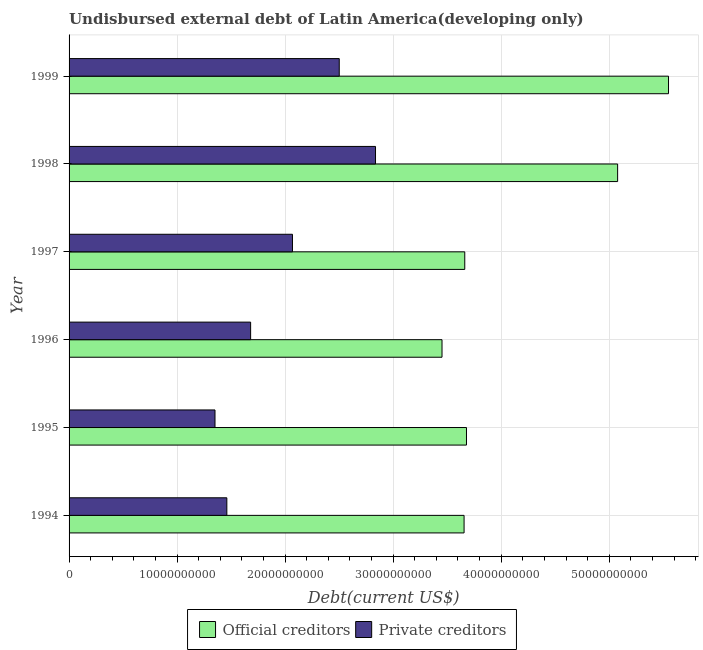Are the number of bars on each tick of the Y-axis equal?
Give a very brief answer. Yes. How many bars are there on the 2nd tick from the top?
Offer a terse response. 2. What is the undisbursed external debt of private creditors in 1994?
Make the answer very short. 1.46e+1. Across all years, what is the maximum undisbursed external debt of private creditors?
Provide a short and direct response. 2.84e+1. Across all years, what is the minimum undisbursed external debt of official creditors?
Offer a terse response. 3.45e+1. In which year was the undisbursed external debt of official creditors maximum?
Your answer should be compact. 1999. What is the total undisbursed external debt of private creditors in the graph?
Offer a terse response. 1.19e+11. What is the difference between the undisbursed external debt of private creditors in 1994 and that in 1999?
Make the answer very short. -1.04e+1. What is the difference between the undisbursed external debt of official creditors in 1996 and the undisbursed external debt of private creditors in 1994?
Your answer should be compact. 1.99e+1. What is the average undisbursed external debt of official creditors per year?
Your answer should be compact. 4.18e+1. In the year 1998, what is the difference between the undisbursed external debt of private creditors and undisbursed external debt of official creditors?
Offer a very short reply. -2.24e+1. In how many years, is the undisbursed external debt of private creditors greater than 48000000000 US$?
Offer a very short reply. 0. What is the ratio of the undisbursed external debt of private creditors in 1995 to that in 1999?
Your answer should be very brief. 0.54. Is the undisbursed external debt of private creditors in 1997 less than that in 1998?
Make the answer very short. Yes. Is the difference between the undisbursed external debt of official creditors in 1997 and 1998 greater than the difference between the undisbursed external debt of private creditors in 1997 and 1998?
Ensure brevity in your answer.  No. What is the difference between the highest and the second highest undisbursed external debt of official creditors?
Offer a very short reply. 4.71e+09. What is the difference between the highest and the lowest undisbursed external debt of official creditors?
Your response must be concise. 2.10e+1. In how many years, is the undisbursed external debt of private creditors greater than the average undisbursed external debt of private creditors taken over all years?
Provide a succinct answer. 3. What does the 2nd bar from the top in 1994 represents?
Make the answer very short. Official creditors. What does the 1st bar from the bottom in 1997 represents?
Provide a short and direct response. Official creditors. How many bars are there?
Your response must be concise. 12. How many years are there in the graph?
Provide a succinct answer. 6. What is the difference between two consecutive major ticks on the X-axis?
Keep it short and to the point. 1.00e+1. Are the values on the major ticks of X-axis written in scientific E-notation?
Offer a terse response. No. Does the graph contain grids?
Provide a short and direct response. Yes. What is the title of the graph?
Provide a succinct answer. Undisbursed external debt of Latin America(developing only). Does "Travel Items" appear as one of the legend labels in the graph?
Your answer should be compact. No. What is the label or title of the X-axis?
Provide a short and direct response. Debt(current US$). What is the Debt(current US$) in Official creditors in 1994?
Provide a short and direct response. 3.66e+1. What is the Debt(current US$) of Private creditors in 1994?
Offer a terse response. 1.46e+1. What is the Debt(current US$) of Official creditors in 1995?
Your response must be concise. 3.68e+1. What is the Debt(current US$) of Private creditors in 1995?
Provide a succinct answer. 1.35e+1. What is the Debt(current US$) of Official creditors in 1996?
Offer a very short reply. 3.45e+1. What is the Debt(current US$) of Private creditors in 1996?
Give a very brief answer. 1.68e+1. What is the Debt(current US$) in Official creditors in 1997?
Your answer should be very brief. 3.66e+1. What is the Debt(current US$) in Private creditors in 1997?
Your answer should be very brief. 2.07e+1. What is the Debt(current US$) of Official creditors in 1998?
Provide a succinct answer. 5.08e+1. What is the Debt(current US$) in Private creditors in 1998?
Provide a succinct answer. 2.84e+1. What is the Debt(current US$) in Official creditors in 1999?
Offer a terse response. 5.55e+1. What is the Debt(current US$) in Private creditors in 1999?
Your answer should be very brief. 2.50e+1. Across all years, what is the maximum Debt(current US$) in Official creditors?
Your answer should be compact. 5.55e+1. Across all years, what is the maximum Debt(current US$) in Private creditors?
Your answer should be very brief. 2.84e+1. Across all years, what is the minimum Debt(current US$) in Official creditors?
Keep it short and to the point. 3.45e+1. Across all years, what is the minimum Debt(current US$) in Private creditors?
Your answer should be compact. 1.35e+1. What is the total Debt(current US$) of Official creditors in the graph?
Provide a short and direct response. 2.51e+11. What is the total Debt(current US$) in Private creditors in the graph?
Offer a terse response. 1.19e+11. What is the difference between the Debt(current US$) in Official creditors in 1994 and that in 1995?
Keep it short and to the point. -2.23e+08. What is the difference between the Debt(current US$) of Private creditors in 1994 and that in 1995?
Keep it short and to the point. 1.10e+09. What is the difference between the Debt(current US$) of Official creditors in 1994 and that in 1996?
Offer a very short reply. 2.04e+09. What is the difference between the Debt(current US$) of Private creditors in 1994 and that in 1996?
Your answer should be very brief. -2.20e+09. What is the difference between the Debt(current US$) in Official creditors in 1994 and that in 1997?
Offer a very short reply. -6.36e+07. What is the difference between the Debt(current US$) in Private creditors in 1994 and that in 1997?
Your answer should be compact. -6.07e+09. What is the difference between the Debt(current US$) in Official creditors in 1994 and that in 1998?
Offer a terse response. -1.42e+1. What is the difference between the Debt(current US$) in Private creditors in 1994 and that in 1998?
Make the answer very short. -1.38e+1. What is the difference between the Debt(current US$) of Official creditors in 1994 and that in 1999?
Give a very brief answer. -1.89e+1. What is the difference between the Debt(current US$) in Private creditors in 1994 and that in 1999?
Your response must be concise. -1.04e+1. What is the difference between the Debt(current US$) of Official creditors in 1995 and that in 1996?
Give a very brief answer. 2.27e+09. What is the difference between the Debt(current US$) of Private creditors in 1995 and that in 1996?
Your response must be concise. -3.30e+09. What is the difference between the Debt(current US$) of Official creditors in 1995 and that in 1997?
Provide a short and direct response. 1.60e+08. What is the difference between the Debt(current US$) of Private creditors in 1995 and that in 1997?
Keep it short and to the point. -7.17e+09. What is the difference between the Debt(current US$) of Official creditors in 1995 and that in 1998?
Provide a succinct answer. -1.40e+1. What is the difference between the Debt(current US$) in Private creditors in 1995 and that in 1998?
Ensure brevity in your answer.  -1.49e+1. What is the difference between the Debt(current US$) in Official creditors in 1995 and that in 1999?
Make the answer very short. -1.87e+1. What is the difference between the Debt(current US$) in Private creditors in 1995 and that in 1999?
Offer a very short reply. -1.15e+1. What is the difference between the Debt(current US$) in Official creditors in 1996 and that in 1997?
Give a very brief answer. -2.11e+09. What is the difference between the Debt(current US$) of Private creditors in 1996 and that in 1997?
Offer a very short reply. -3.87e+09. What is the difference between the Debt(current US$) of Official creditors in 1996 and that in 1998?
Provide a short and direct response. -1.63e+1. What is the difference between the Debt(current US$) of Private creditors in 1996 and that in 1998?
Make the answer very short. -1.16e+1. What is the difference between the Debt(current US$) of Official creditors in 1996 and that in 1999?
Your response must be concise. -2.10e+1. What is the difference between the Debt(current US$) in Private creditors in 1996 and that in 1999?
Give a very brief answer. -8.20e+09. What is the difference between the Debt(current US$) of Official creditors in 1997 and that in 1998?
Offer a very short reply. -1.42e+1. What is the difference between the Debt(current US$) in Private creditors in 1997 and that in 1998?
Keep it short and to the point. -7.69e+09. What is the difference between the Debt(current US$) in Official creditors in 1997 and that in 1999?
Offer a very short reply. -1.89e+1. What is the difference between the Debt(current US$) of Private creditors in 1997 and that in 1999?
Keep it short and to the point. -4.33e+09. What is the difference between the Debt(current US$) in Official creditors in 1998 and that in 1999?
Make the answer very short. -4.71e+09. What is the difference between the Debt(current US$) of Private creditors in 1998 and that in 1999?
Your answer should be very brief. 3.36e+09. What is the difference between the Debt(current US$) of Official creditors in 1994 and the Debt(current US$) of Private creditors in 1995?
Offer a very short reply. 2.31e+1. What is the difference between the Debt(current US$) in Official creditors in 1994 and the Debt(current US$) in Private creditors in 1996?
Ensure brevity in your answer.  1.98e+1. What is the difference between the Debt(current US$) in Official creditors in 1994 and the Debt(current US$) in Private creditors in 1997?
Your response must be concise. 1.59e+1. What is the difference between the Debt(current US$) of Official creditors in 1994 and the Debt(current US$) of Private creditors in 1998?
Keep it short and to the point. 8.20e+09. What is the difference between the Debt(current US$) of Official creditors in 1994 and the Debt(current US$) of Private creditors in 1999?
Your response must be concise. 1.16e+1. What is the difference between the Debt(current US$) in Official creditors in 1995 and the Debt(current US$) in Private creditors in 1996?
Your answer should be very brief. 2.00e+1. What is the difference between the Debt(current US$) of Official creditors in 1995 and the Debt(current US$) of Private creditors in 1997?
Give a very brief answer. 1.61e+1. What is the difference between the Debt(current US$) in Official creditors in 1995 and the Debt(current US$) in Private creditors in 1998?
Offer a very short reply. 8.42e+09. What is the difference between the Debt(current US$) in Official creditors in 1995 and the Debt(current US$) in Private creditors in 1999?
Your answer should be compact. 1.18e+1. What is the difference between the Debt(current US$) of Official creditors in 1996 and the Debt(current US$) of Private creditors in 1997?
Your answer should be very brief. 1.38e+1. What is the difference between the Debt(current US$) in Official creditors in 1996 and the Debt(current US$) in Private creditors in 1998?
Give a very brief answer. 6.16e+09. What is the difference between the Debt(current US$) of Official creditors in 1996 and the Debt(current US$) of Private creditors in 1999?
Provide a short and direct response. 9.51e+09. What is the difference between the Debt(current US$) in Official creditors in 1997 and the Debt(current US$) in Private creditors in 1998?
Make the answer very short. 8.26e+09. What is the difference between the Debt(current US$) of Official creditors in 1997 and the Debt(current US$) of Private creditors in 1999?
Provide a succinct answer. 1.16e+1. What is the difference between the Debt(current US$) of Official creditors in 1998 and the Debt(current US$) of Private creditors in 1999?
Ensure brevity in your answer.  2.58e+1. What is the average Debt(current US$) of Official creditors per year?
Give a very brief answer. 4.18e+1. What is the average Debt(current US$) of Private creditors per year?
Offer a terse response. 1.98e+1. In the year 1994, what is the difference between the Debt(current US$) in Official creditors and Debt(current US$) in Private creditors?
Your response must be concise. 2.20e+1. In the year 1995, what is the difference between the Debt(current US$) of Official creditors and Debt(current US$) of Private creditors?
Give a very brief answer. 2.33e+1. In the year 1996, what is the difference between the Debt(current US$) in Official creditors and Debt(current US$) in Private creditors?
Offer a terse response. 1.77e+1. In the year 1997, what is the difference between the Debt(current US$) of Official creditors and Debt(current US$) of Private creditors?
Your answer should be very brief. 1.59e+1. In the year 1998, what is the difference between the Debt(current US$) of Official creditors and Debt(current US$) of Private creditors?
Offer a terse response. 2.24e+1. In the year 1999, what is the difference between the Debt(current US$) in Official creditors and Debt(current US$) in Private creditors?
Keep it short and to the point. 3.05e+1. What is the ratio of the Debt(current US$) in Official creditors in 1994 to that in 1995?
Offer a very short reply. 0.99. What is the ratio of the Debt(current US$) in Private creditors in 1994 to that in 1995?
Offer a terse response. 1.08. What is the ratio of the Debt(current US$) in Official creditors in 1994 to that in 1996?
Provide a succinct answer. 1.06. What is the ratio of the Debt(current US$) in Private creditors in 1994 to that in 1996?
Make the answer very short. 0.87. What is the ratio of the Debt(current US$) in Official creditors in 1994 to that in 1997?
Give a very brief answer. 1. What is the ratio of the Debt(current US$) in Private creditors in 1994 to that in 1997?
Provide a succinct answer. 0.71. What is the ratio of the Debt(current US$) of Official creditors in 1994 to that in 1998?
Give a very brief answer. 0.72. What is the ratio of the Debt(current US$) of Private creditors in 1994 to that in 1998?
Keep it short and to the point. 0.51. What is the ratio of the Debt(current US$) in Official creditors in 1994 to that in 1999?
Provide a short and direct response. 0.66. What is the ratio of the Debt(current US$) in Private creditors in 1994 to that in 1999?
Offer a very short reply. 0.58. What is the ratio of the Debt(current US$) of Official creditors in 1995 to that in 1996?
Your answer should be compact. 1.07. What is the ratio of the Debt(current US$) in Private creditors in 1995 to that in 1996?
Keep it short and to the point. 0.8. What is the ratio of the Debt(current US$) of Official creditors in 1995 to that in 1997?
Offer a terse response. 1. What is the ratio of the Debt(current US$) in Private creditors in 1995 to that in 1997?
Your response must be concise. 0.65. What is the ratio of the Debt(current US$) in Official creditors in 1995 to that in 1998?
Your answer should be very brief. 0.72. What is the ratio of the Debt(current US$) of Private creditors in 1995 to that in 1998?
Keep it short and to the point. 0.48. What is the ratio of the Debt(current US$) in Official creditors in 1995 to that in 1999?
Keep it short and to the point. 0.66. What is the ratio of the Debt(current US$) of Private creditors in 1995 to that in 1999?
Your answer should be very brief. 0.54. What is the ratio of the Debt(current US$) of Official creditors in 1996 to that in 1997?
Ensure brevity in your answer.  0.94. What is the ratio of the Debt(current US$) of Private creditors in 1996 to that in 1997?
Provide a succinct answer. 0.81. What is the ratio of the Debt(current US$) of Official creditors in 1996 to that in 1998?
Keep it short and to the point. 0.68. What is the ratio of the Debt(current US$) of Private creditors in 1996 to that in 1998?
Your answer should be very brief. 0.59. What is the ratio of the Debt(current US$) in Official creditors in 1996 to that in 1999?
Provide a succinct answer. 0.62. What is the ratio of the Debt(current US$) in Private creditors in 1996 to that in 1999?
Ensure brevity in your answer.  0.67. What is the ratio of the Debt(current US$) of Official creditors in 1997 to that in 1998?
Provide a short and direct response. 0.72. What is the ratio of the Debt(current US$) of Private creditors in 1997 to that in 1998?
Offer a terse response. 0.73. What is the ratio of the Debt(current US$) in Official creditors in 1997 to that in 1999?
Provide a short and direct response. 0.66. What is the ratio of the Debt(current US$) in Private creditors in 1997 to that in 1999?
Offer a terse response. 0.83. What is the ratio of the Debt(current US$) in Official creditors in 1998 to that in 1999?
Provide a succinct answer. 0.92. What is the ratio of the Debt(current US$) in Private creditors in 1998 to that in 1999?
Offer a very short reply. 1.13. What is the difference between the highest and the second highest Debt(current US$) of Official creditors?
Offer a terse response. 4.71e+09. What is the difference between the highest and the second highest Debt(current US$) in Private creditors?
Offer a terse response. 3.36e+09. What is the difference between the highest and the lowest Debt(current US$) in Official creditors?
Offer a terse response. 2.10e+1. What is the difference between the highest and the lowest Debt(current US$) in Private creditors?
Offer a very short reply. 1.49e+1. 